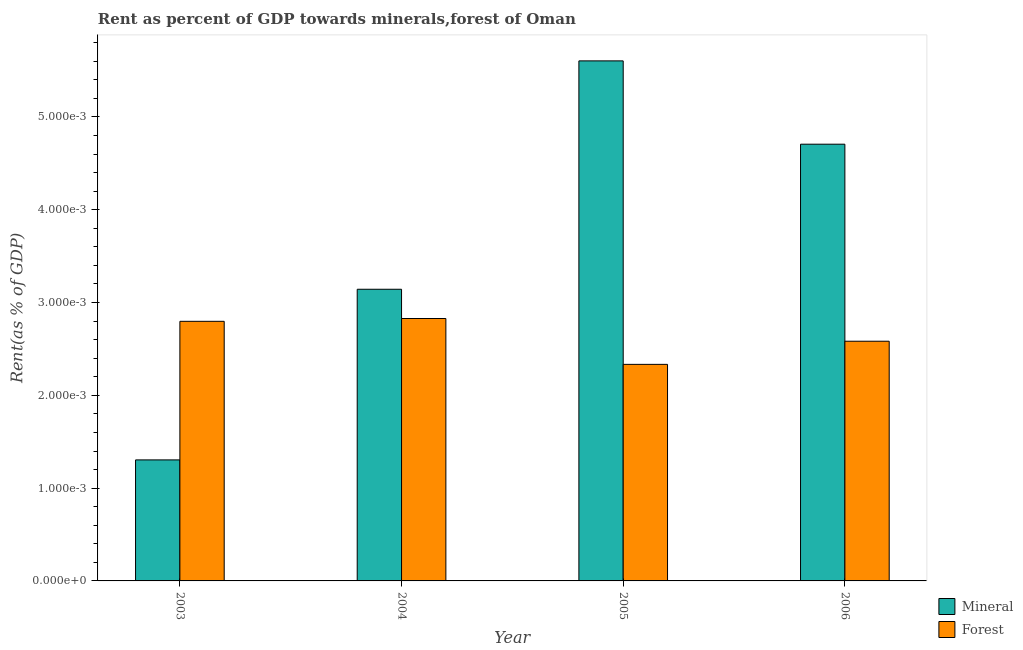How many different coloured bars are there?
Give a very brief answer. 2. How many groups of bars are there?
Make the answer very short. 4. How many bars are there on the 4th tick from the left?
Keep it short and to the point. 2. How many bars are there on the 1st tick from the right?
Provide a short and direct response. 2. What is the mineral rent in 2005?
Make the answer very short. 0.01. Across all years, what is the maximum forest rent?
Keep it short and to the point. 0. Across all years, what is the minimum forest rent?
Offer a terse response. 0. What is the total mineral rent in the graph?
Make the answer very short. 0.01. What is the difference between the mineral rent in 2003 and that in 2006?
Make the answer very short. -0. What is the difference between the mineral rent in 2006 and the forest rent in 2003?
Your response must be concise. 0. What is the average forest rent per year?
Provide a short and direct response. 0. In how many years, is the forest rent greater than 0.0008 %?
Provide a succinct answer. 4. What is the ratio of the forest rent in 2003 to that in 2005?
Give a very brief answer. 1.2. Is the difference between the forest rent in 2003 and 2005 greater than the difference between the mineral rent in 2003 and 2005?
Offer a terse response. No. What is the difference between the highest and the second highest forest rent?
Provide a succinct answer. 3.0356574191300022e-5. What is the difference between the highest and the lowest forest rent?
Provide a succinct answer. 0. In how many years, is the forest rent greater than the average forest rent taken over all years?
Ensure brevity in your answer.  2. What does the 2nd bar from the left in 2005 represents?
Offer a very short reply. Forest. What does the 2nd bar from the right in 2006 represents?
Keep it short and to the point. Mineral. How many years are there in the graph?
Offer a terse response. 4. What is the difference between two consecutive major ticks on the Y-axis?
Your answer should be very brief. 0. Are the values on the major ticks of Y-axis written in scientific E-notation?
Offer a terse response. Yes. Does the graph contain grids?
Your response must be concise. No. How many legend labels are there?
Provide a short and direct response. 2. What is the title of the graph?
Make the answer very short. Rent as percent of GDP towards minerals,forest of Oman. Does "Stunting" appear as one of the legend labels in the graph?
Give a very brief answer. No. What is the label or title of the Y-axis?
Your answer should be compact. Rent(as % of GDP). What is the Rent(as % of GDP) in Mineral in 2003?
Offer a terse response. 0. What is the Rent(as % of GDP) in Forest in 2003?
Offer a very short reply. 0. What is the Rent(as % of GDP) of Mineral in 2004?
Make the answer very short. 0. What is the Rent(as % of GDP) of Forest in 2004?
Give a very brief answer. 0. What is the Rent(as % of GDP) of Mineral in 2005?
Your answer should be very brief. 0.01. What is the Rent(as % of GDP) in Forest in 2005?
Provide a short and direct response. 0. What is the Rent(as % of GDP) of Mineral in 2006?
Offer a very short reply. 0. What is the Rent(as % of GDP) of Forest in 2006?
Your response must be concise. 0. Across all years, what is the maximum Rent(as % of GDP) in Mineral?
Give a very brief answer. 0.01. Across all years, what is the maximum Rent(as % of GDP) of Forest?
Make the answer very short. 0. Across all years, what is the minimum Rent(as % of GDP) in Mineral?
Your response must be concise. 0. Across all years, what is the minimum Rent(as % of GDP) of Forest?
Provide a short and direct response. 0. What is the total Rent(as % of GDP) of Mineral in the graph?
Ensure brevity in your answer.  0.01. What is the total Rent(as % of GDP) in Forest in the graph?
Offer a terse response. 0.01. What is the difference between the Rent(as % of GDP) of Mineral in 2003 and that in 2004?
Provide a succinct answer. -0. What is the difference between the Rent(as % of GDP) in Forest in 2003 and that in 2004?
Your answer should be very brief. -0. What is the difference between the Rent(as % of GDP) of Mineral in 2003 and that in 2005?
Keep it short and to the point. -0. What is the difference between the Rent(as % of GDP) in Forest in 2003 and that in 2005?
Offer a very short reply. 0. What is the difference between the Rent(as % of GDP) of Mineral in 2003 and that in 2006?
Your answer should be compact. -0. What is the difference between the Rent(as % of GDP) in Mineral in 2004 and that in 2005?
Offer a terse response. -0. What is the difference between the Rent(as % of GDP) of Forest in 2004 and that in 2005?
Keep it short and to the point. 0. What is the difference between the Rent(as % of GDP) of Mineral in 2004 and that in 2006?
Provide a short and direct response. -0. What is the difference between the Rent(as % of GDP) in Mineral in 2005 and that in 2006?
Your response must be concise. 0. What is the difference between the Rent(as % of GDP) of Forest in 2005 and that in 2006?
Your answer should be compact. -0. What is the difference between the Rent(as % of GDP) of Mineral in 2003 and the Rent(as % of GDP) of Forest in 2004?
Provide a succinct answer. -0. What is the difference between the Rent(as % of GDP) in Mineral in 2003 and the Rent(as % of GDP) in Forest in 2005?
Ensure brevity in your answer.  -0. What is the difference between the Rent(as % of GDP) in Mineral in 2003 and the Rent(as % of GDP) in Forest in 2006?
Your answer should be very brief. -0. What is the difference between the Rent(as % of GDP) of Mineral in 2004 and the Rent(as % of GDP) of Forest in 2005?
Your answer should be compact. 0. What is the difference between the Rent(as % of GDP) of Mineral in 2004 and the Rent(as % of GDP) of Forest in 2006?
Give a very brief answer. 0. What is the difference between the Rent(as % of GDP) of Mineral in 2005 and the Rent(as % of GDP) of Forest in 2006?
Your answer should be very brief. 0. What is the average Rent(as % of GDP) in Mineral per year?
Offer a terse response. 0. What is the average Rent(as % of GDP) in Forest per year?
Provide a short and direct response. 0. In the year 2003, what is the difference between the Rent(as % of GDP) in Mineral and Rent(as % of GDP) in Forest?
Keep it short and to the point. -0. In the year 2005, what is the difference between the Rent(as % of GDP) in Mineral and Rent(as % of GDP) in Forest?
Make the answer very short. 0. In the year 2006, what is the difference between the Rent(as % of GDP) in Mineral and Rent(as % of GDP) in Forest?
Provide a succinct answer. 0. What is the ratio of the Rent(as % of GDP) in Mineral in 2003 to that in 2004?
Keep it short and to the point. 0.41. What is the ratio of the Rent(as % of GDP) in Forest in 2003 to that in 2004?
Provide a short and direct response. 0.99. What is the ratio of the Rent(as % of GDP) in Mineral in 2003 to that in 2005?
Ensure brevity in your answer.  0.23. What is the ratio of the Rent(as % of GDP) of Forest in 2003 to that in 2005?
Offer a very short reply. 1.2. What is the ratio of the Rent(as % of GDP) of Mineral in 2003 to that in 2006?
Make the answer very short. 0.28. What is the ratio of the Rent(as % of GDP) of Forest in 2003 to that in 2006?
Ensure brevity in your answer.  1.08. What is the ratio of the Rent(as % of GDP) of Mineral in 2004 to that in 2005?
Keep it short and to the point. 0.56. What is the ratio of the Rent(as % of GDP) of Forest in 2004 to that in 2005?
Offer a very short reply. 1.21. What is the ratio of the Rent(as % of GDP) in Mineral in 2004 to that in 2006?
Provide a short and direct response. 0.67. What is the ratio of the Rent(as % of GDP) of Forest in 2004 to that in 2006?
Make the answer very short. 1.09. What is the ratio of the Rent(as % of GDP) of Mineral in 2005 to that in 2006?
Make the answer very short. 1.19. What is the ratio of the Rent(as % of GDP) in Forest in 2005 to that in 2006?
Your answer should be compact. 0.9. What is the difference between the highest and the second highest Rent(as % of GDP) in Mineral?
Provide a succinct answer. 0. What is the difference between the highest and the second highest Rent(as % of GDP) in Forest?
Ensure brevity in your answer.  0. What is the difference between the highest and the lowest Rent(as % of GDP) of Mineral?
Provide a succinct answer. 0. 